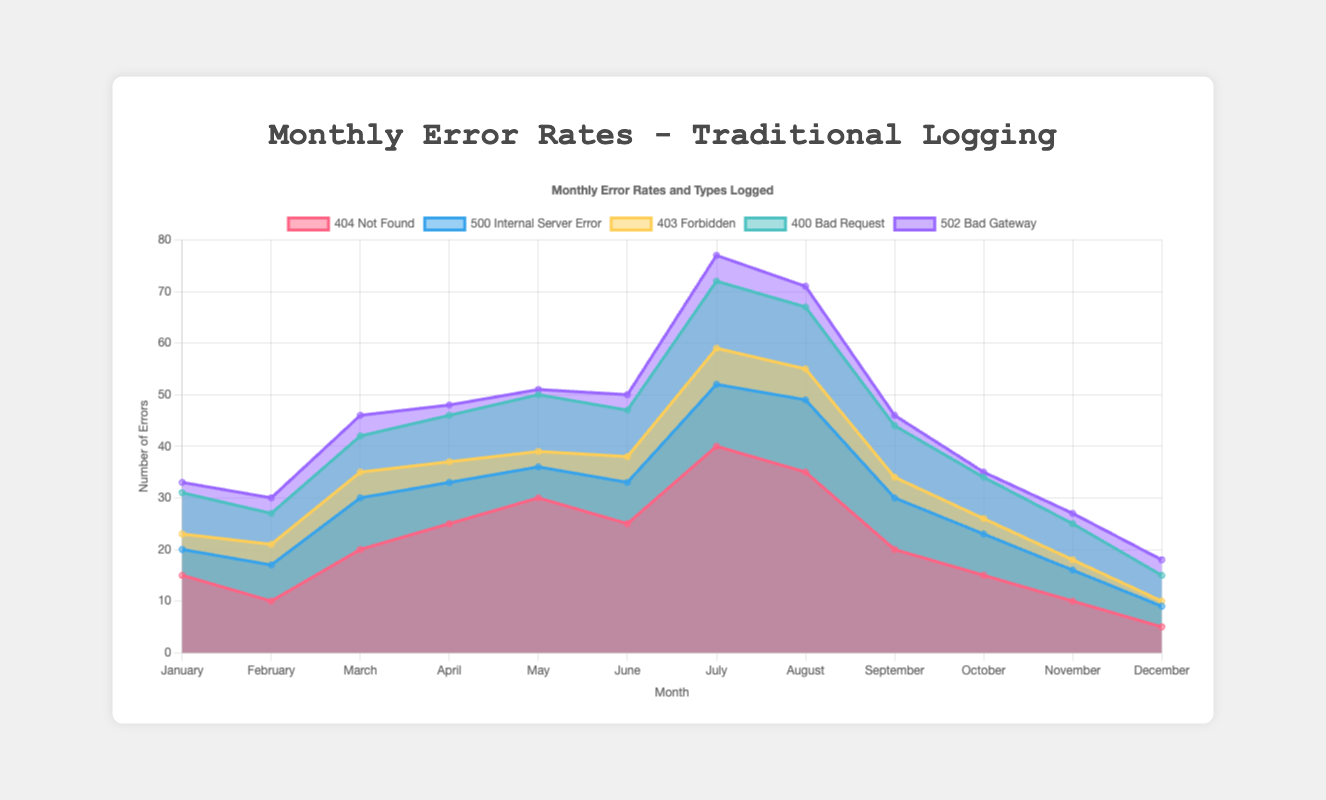What is the title of the chart? The title can be found at the top of the chart, and it provides a brief description of the data being presented.
Answer: Monthly Error Rates and Types Logged How many types of errors are displayed on the chart? Each dataset represents a different type of error, denoted by different colors and labels in the legend.
Answer: 5 Which month has the highest number of 404 Not Found errors? By looking at the data points for the 404 Not Found dataset, the highest point can be observed in July.
Answer: July Which error type recorded the most errors in June? Comparing the data points for each error type in June, the 404 Not Found error has the highest value.
Answer: 404 Not Found In which month did the 400 Bad Request errors peak? The peak can be identified by finding the highest point for the 400 Bad Request dataset, which occurs in May.
Answer: May What is the total number of 500 Internal Server Error occurrences in the year? Summing up the data points for the 500 Internal Server Error dataset: 5 + 7 + 10 + 8 + 6 + 8 + 12 + 14 + 10 + 8 + 6 + 4 = 98
Answer: 98 Compare the number of 403 Forbidden errors in January and December. Which month had more and by how much? January has 3 errors and December has 1 error for 403 Forbidden. The difference is 3 - 1 = 2.
Answer: January, by 2 What is the average number of errors for 502 Bad Gateway over the entire year? Summing up the 502 Bad Gateway errors and dividing by 12 (number of months): (2 + 3 + 4 + 2 + 1 + 3 + 5 + 4 + 2 + 1 + 2 + 3) / 12 = 32 / 12 ≈ 2.67
Answer: 2.67 Which month has the least total number of logged errors across all types? Sum the errors for each month and compare: January (33), February (30), March (46), April (48), May (51), June (50), July (77), August (71), September (46), October (35), November (27), December (18). December has the least total with 18 errors.
Answer: December How did the number of 404 Not Found errors trend from June to July? Observe the change in data points for the 404 Not Found dataset from June to July, which shows an increase from 25 to 40.
Answer: Increased 